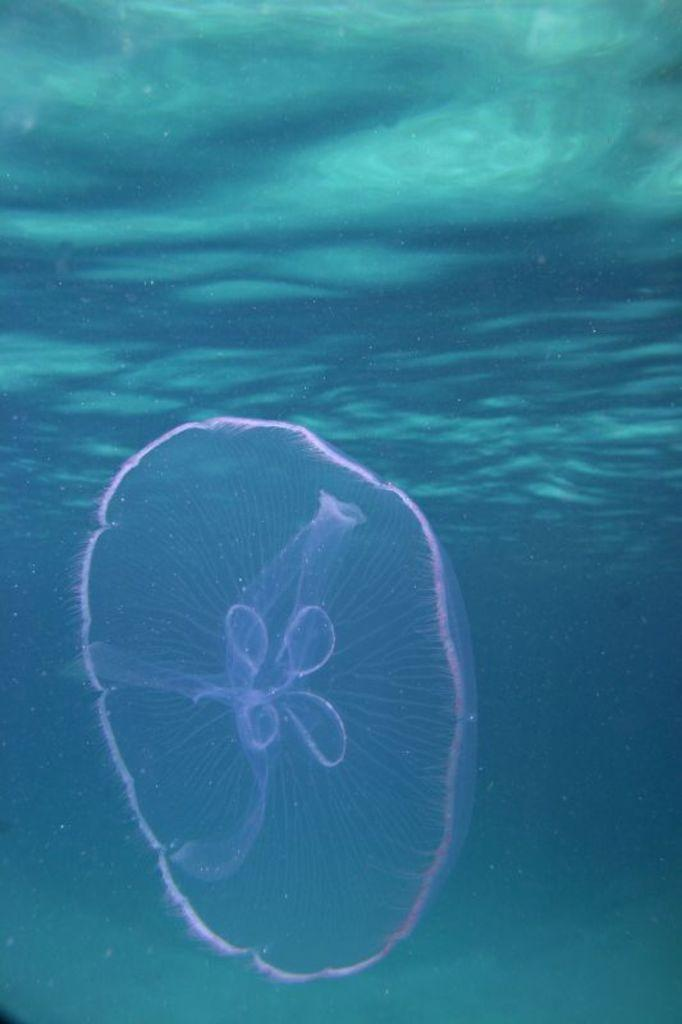What is the main subject of the image? The main subject of the image is a jellyfish. Where is the jellyfish located? The jellyfish is in the water. How does the jellyfish demand attention in the image? The jellyfish does not demand attention in the image; it is simply a subject in the picture. 